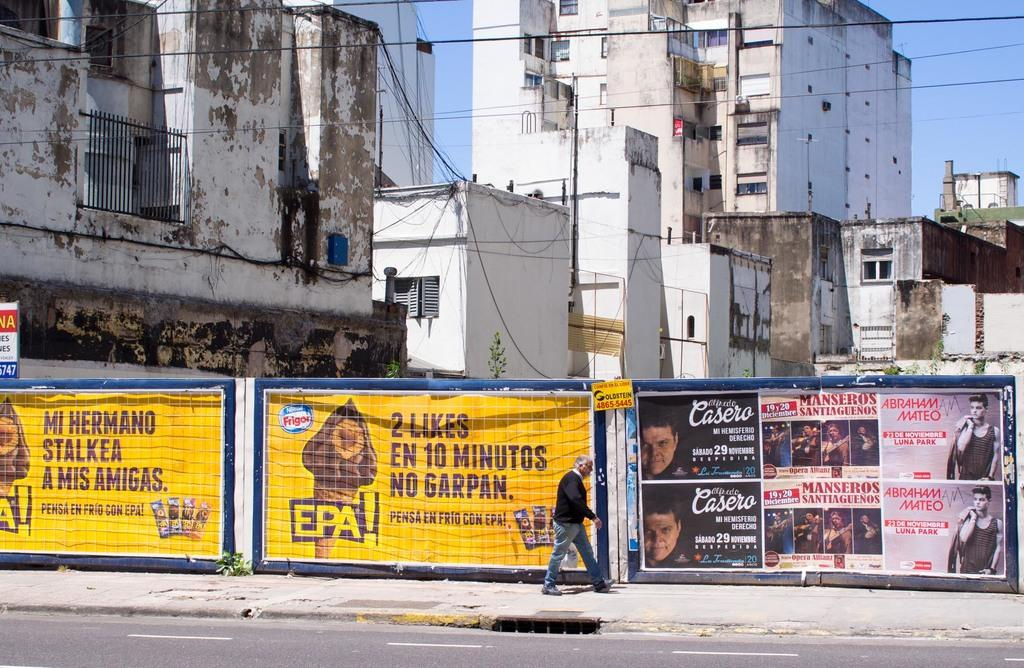Provide a one-sentence caption for the provided image. A yellow sign that says EPA! is in front of an old factory building. 